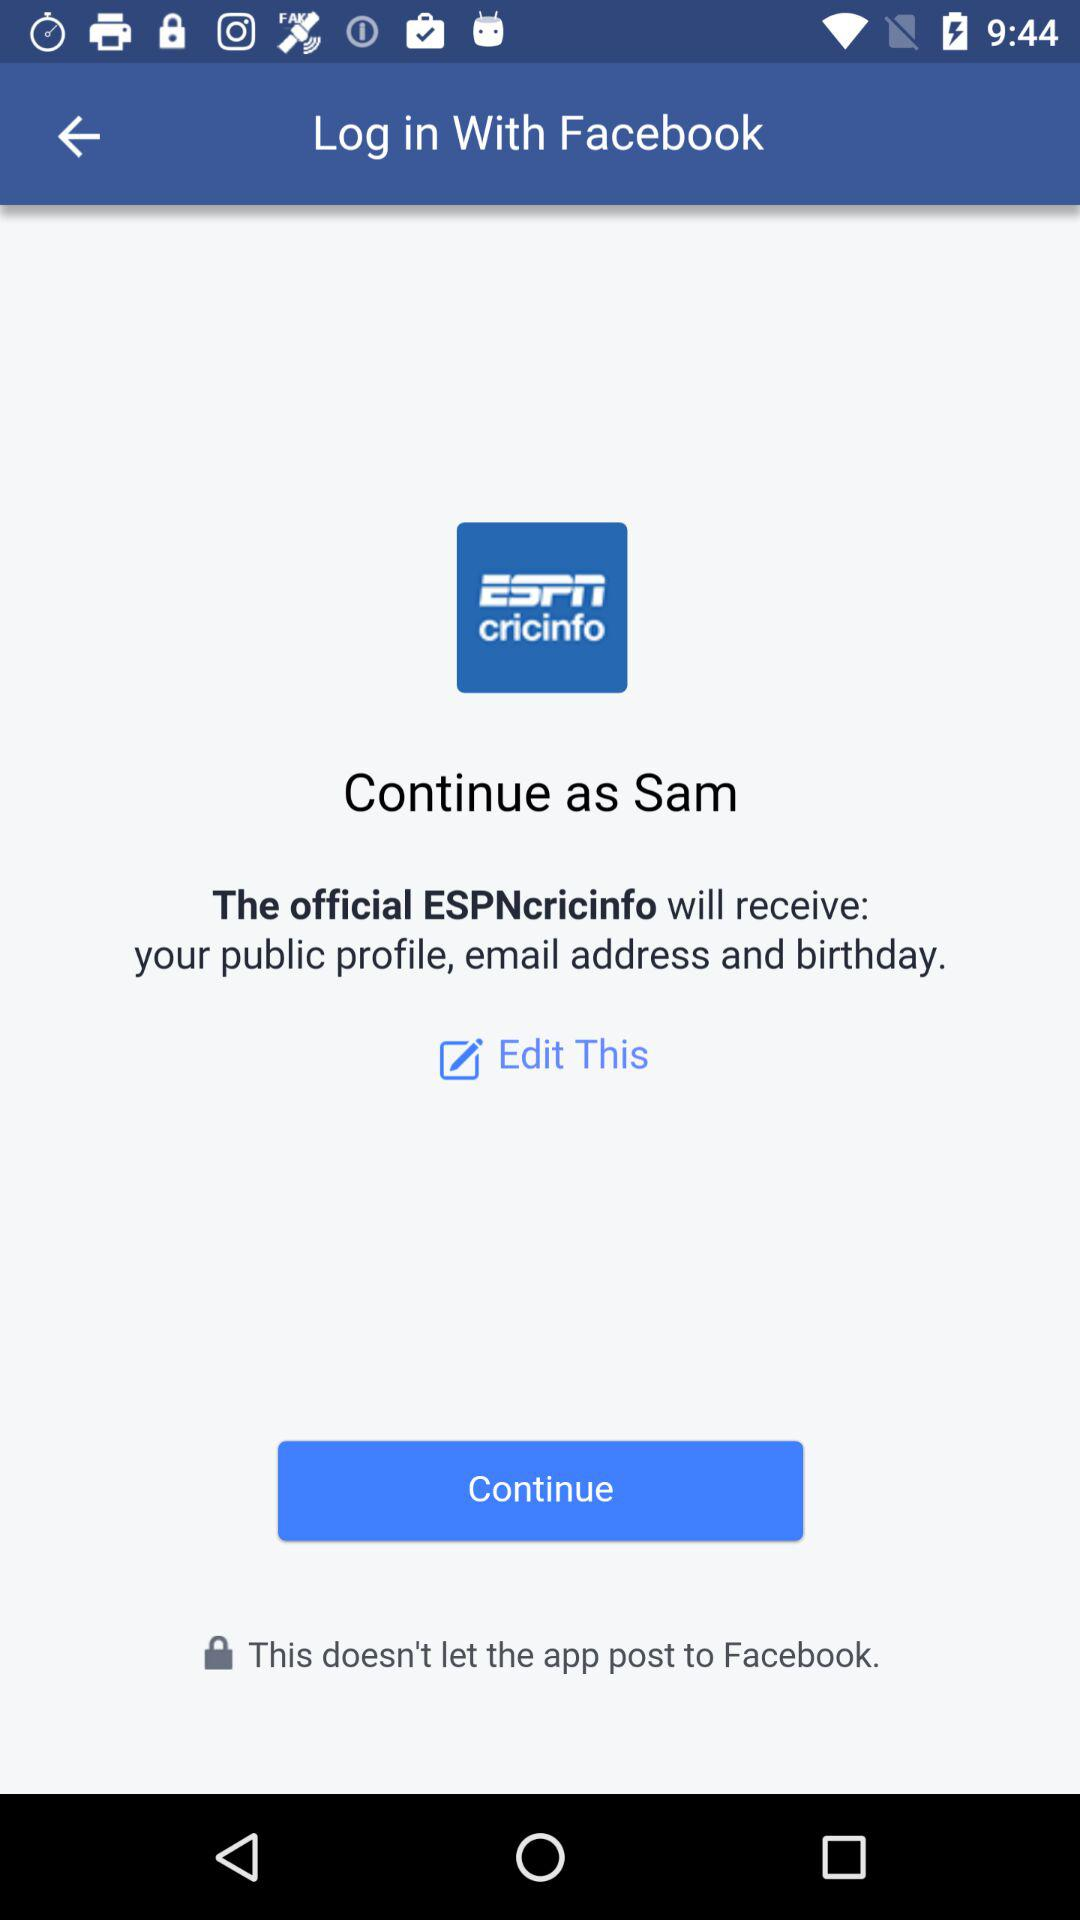What is the login name? The login name is Sam. 